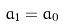<formula> <loc_0><loc_0><loc_500><loc_500>a _ { 1 } = a _ { 0 }</formula> 